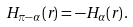<formula> <loc_0><loc_0><loc_500><loc_500>H _ { \pi - \alpha } ( r ) = - H _ { \alpha } ( r ) \, .</formula> 